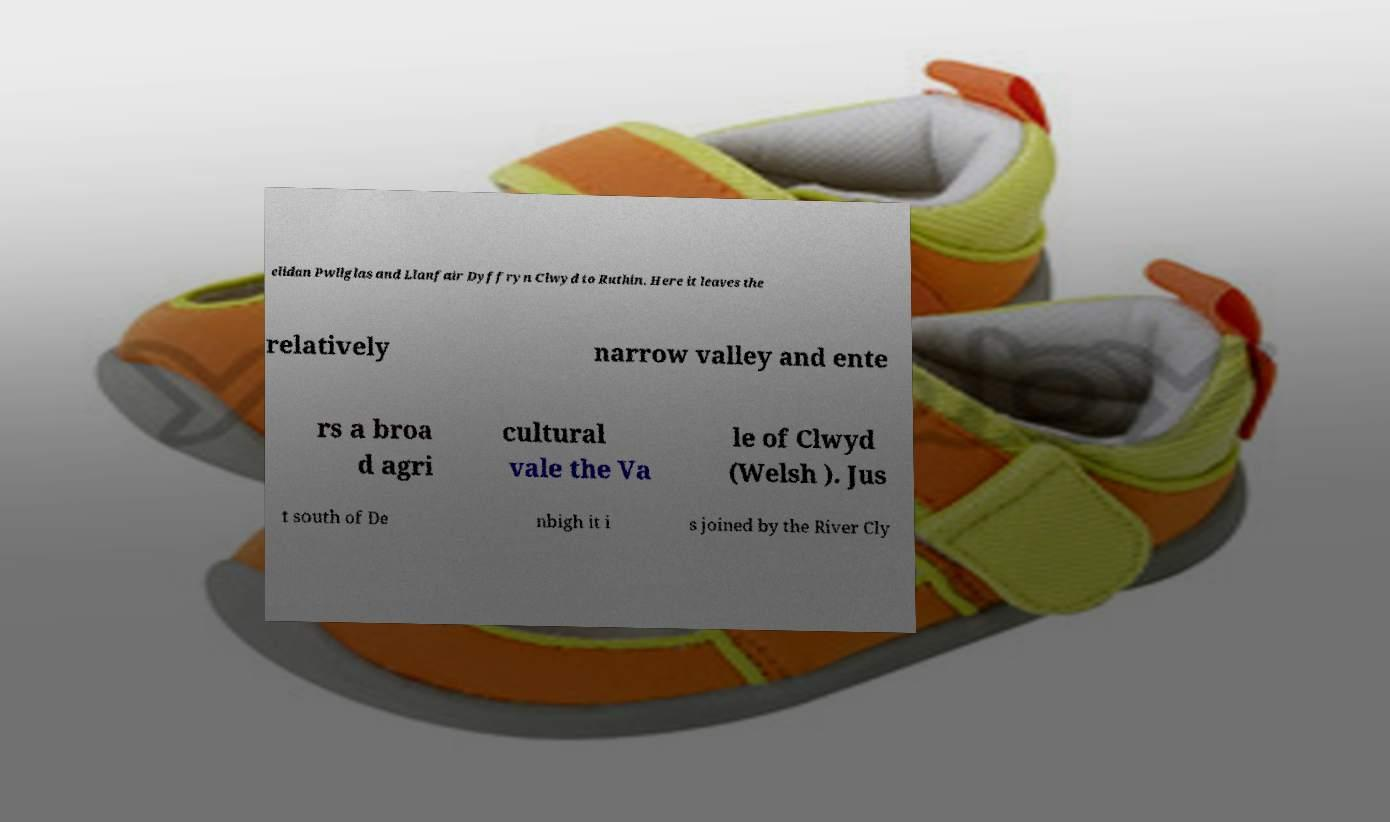Could you assist in decoding the text presented in this image and type it out clearly? elidan Pwllglas and Llanfair Dyffryn Clwyd to Ruthin. Here it leaves the relatively narrow valley and ente rs a broa d agri cultural vale the Va le of Clwyd (Welsh ). Jus t south of De nbigh it i s joined by the River Cly 